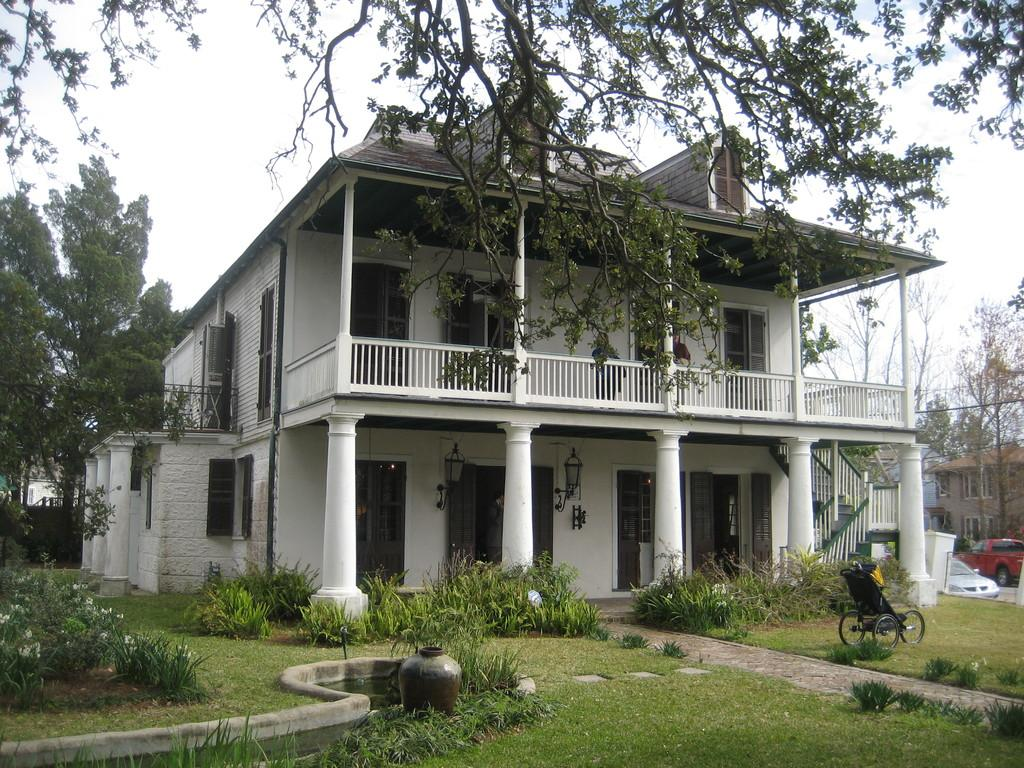What type of structures can be seen in the image? There are buildings in the image. What natural elements are present in the image? There are trees, grass, and plants in the image. What architectural features can be observed in the image? There are windows in the image. What mode of transportation is visible in the image? There are vehicles in the image. Can you describe a specific object in the image? There is a black color wheelchair in the image. What type of wine is being served to the friend in the image? There is no wine or friend present in the image. Can you describe the yak that is grazing in the grass in the image? There is no yak present in the image; it features buildings, trees, grass, plants, windows, vehicles, and a black color wheelchair. 